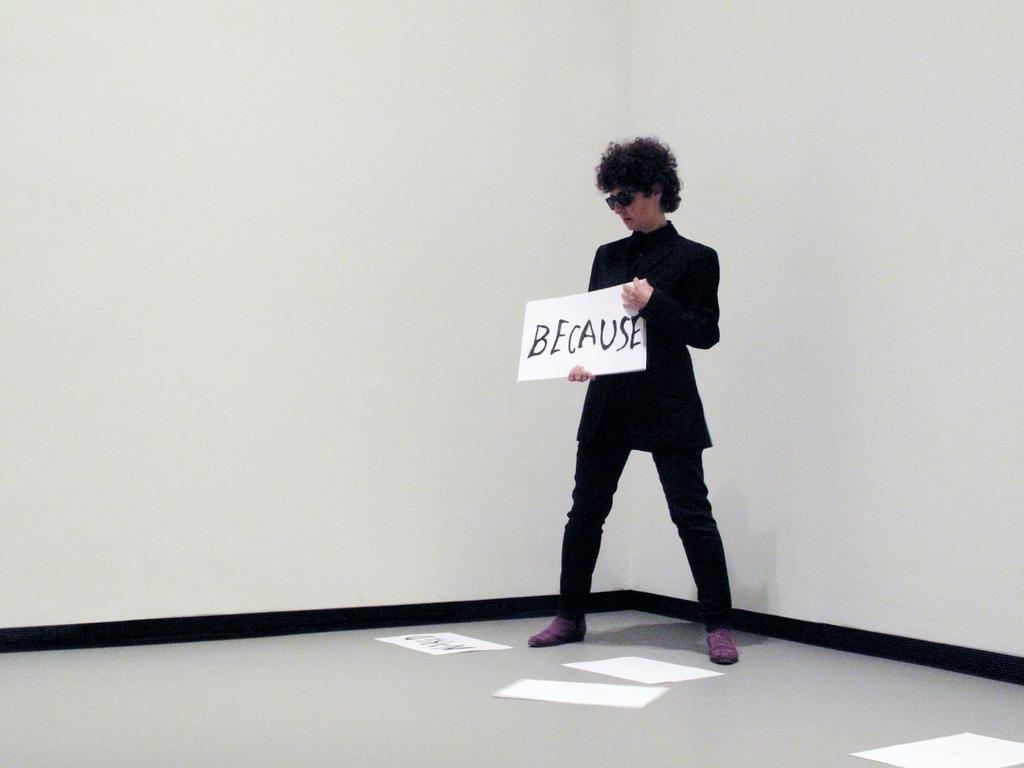Please provide a concise description of this image. In the picture I can see a man is standing and holding a board in hands. In the background I can see white color walls and some papers on the floor. 